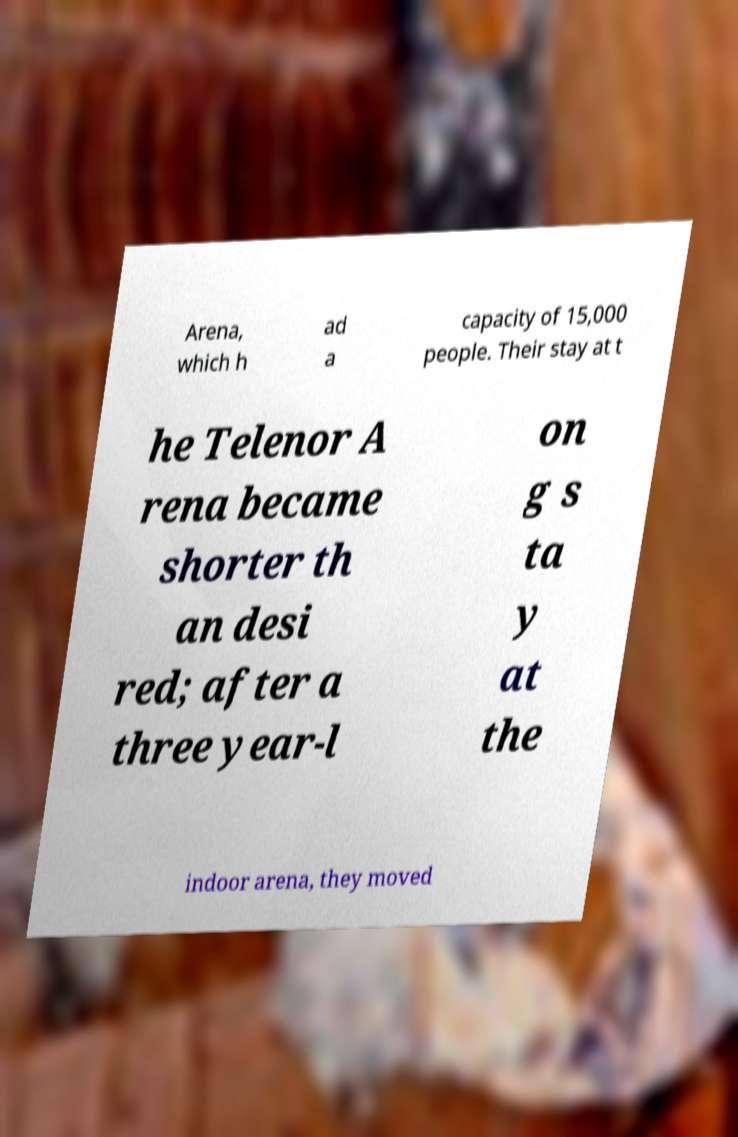For documentation purposes, I need the text within this image transcribed. Could you provide that? Arena, which h ad a capacity of 15,000 people. Their stay at t he Telenor A rena became shorter th an desi red; after a three year-l on g s ta y at the indoor arena, they moved 